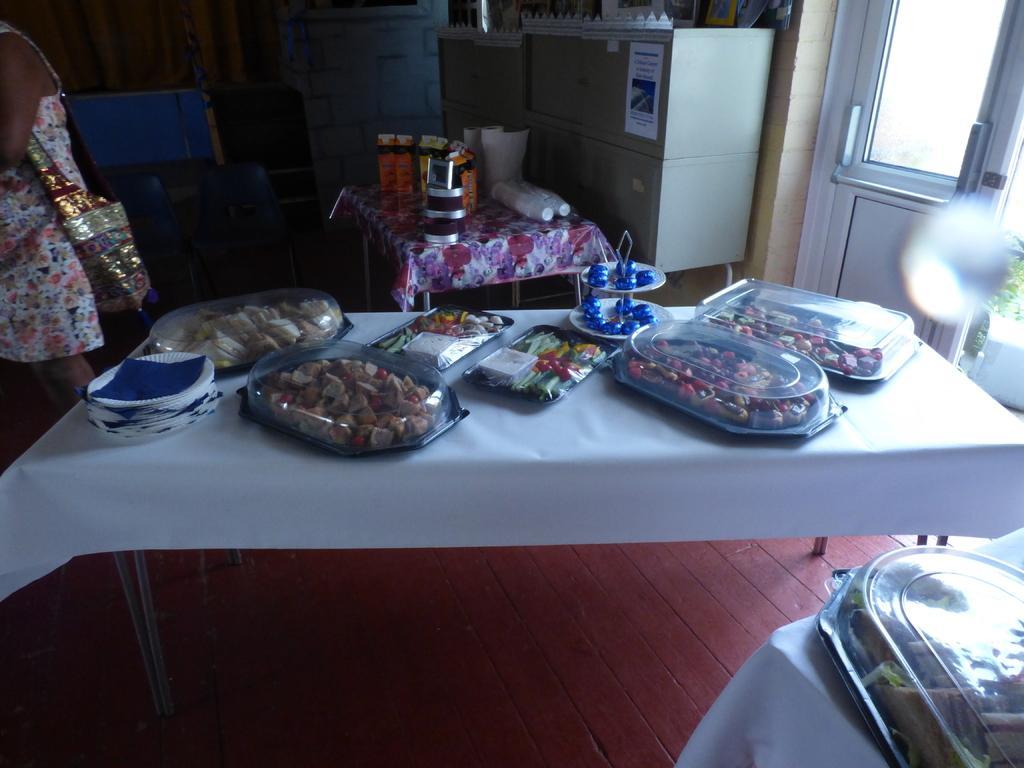In one or two sentences, can you explain what this image depicts? In this image there is a table, on that table there are some dishes, behind that there is another table on that there are some cups and packets, beside that there is woman, in the background there is a wall. 